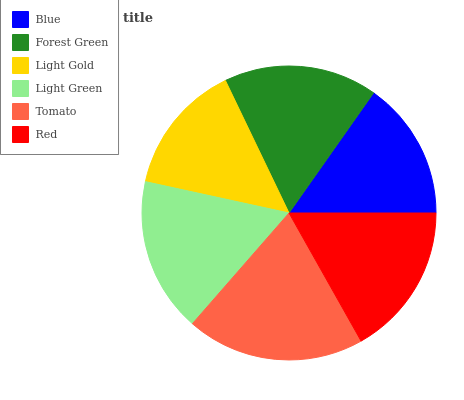Is Light Gold the minimum?
Answer yes or no. Yes. Is Tomato the maximum?
Answer yes or no. Yes. Is Forest Green the minimum?
Answer yes or no. No. Is Forest Green the maximum?
Answer yes or no. No. Is Forest Green greater than Blue?
Answer yes or no. Yes. Is Blue less than Forest Green?
Answer yes or no. Yes. Is Blue greater than Forest Green?
Answer yes or no. No. Is Forest Green less than Blue?
Answer yes or no. No. Is Forest Green the high median?
Answer yes or no. Yes. Is Red the low median?
Answer yes or no. Yes. Is Light Green the high median?
Answer yes or no. No. Is Blue the low median?
Answer yes or no. No. 